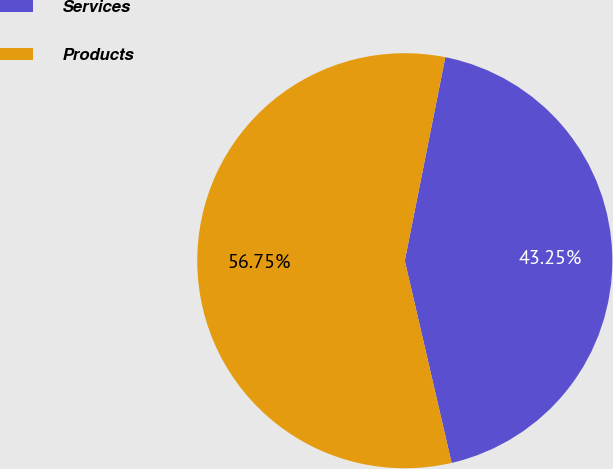Convert chart. <chart><loc_0><loc_0><loc_500><loc_500><pie_chart><fcel>Services<fcel>Products<nl><fcel>43.25%<fcel>56.75%<nl></chart> 